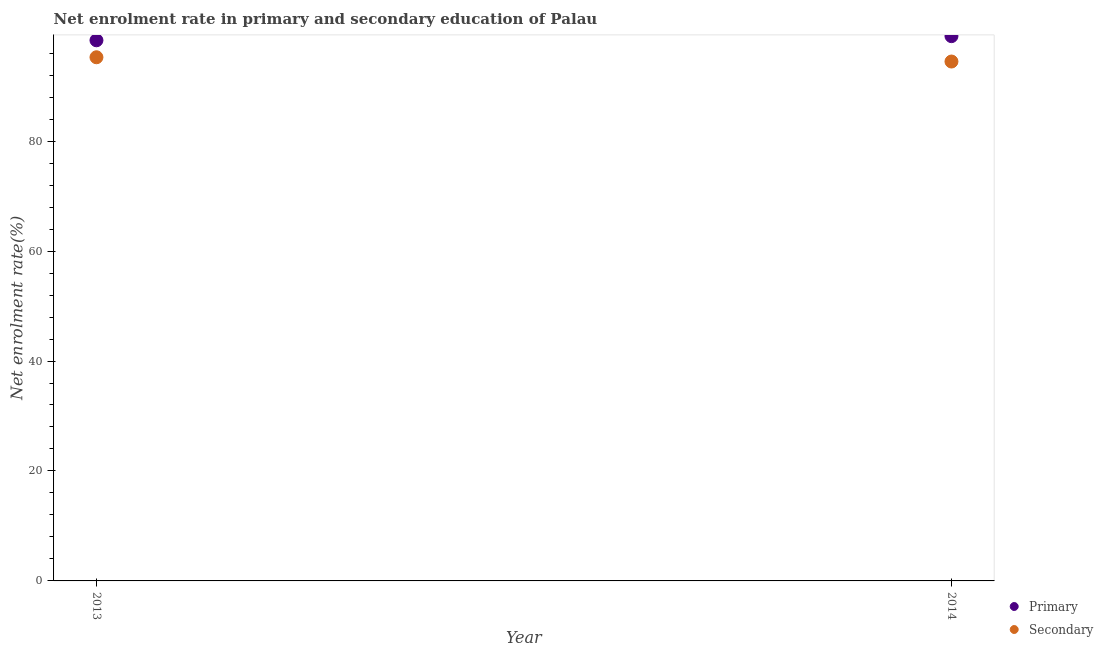What is the enrollment rate in secondary education in 2014?
Give a very brief answer. 94.48. Across all years, what is the maximum enrollment rate in secondary education?
Provide a succinct answer. 95.25. Across all years, what is the minimum enrollment rate in primary education?
Your response must be concise. 98.34. In which year was the enrollment rate in primary education minimum?
Make the answer very short. 2013. What is the total enrollment rate in primary education in the graph?
Your answer should be compact. 197.43. What is the difference between the enrollment rate in primary education in 2013 and that in 2014?
Offer a terse response. -0.75. What is the difference between the enrollment rate in primary education in 2014 and the enrollment rate in secondary education in 2013?
Provide a succinct answer. 3.84. What is the average enrollment rate in primary education per year?
Offer a very short reply. 98.72. In the year 2014, what is the difference between the enrollment rate in secondary education and enrollment rate in primary education?
Ensure brevity in your answer.  -4.62. What is the ratio of the enrollment rate in primary education in 2013 to that in 2014?
Ensure brevity in your answer.  0.99. Is the enrollment rate in primary education in 2013 less than that in 2014?
Keep it short and to the point. Yes. Does the enrollment rate in primary education monotonically increase over the years?
Provide a succinct answer. Yes. Is the enrollment rate in secondary education strictly greater than the enrollment rate in primary education over the years?
Make the answer very short. No. How many years are there in the graph?
Keep it short and to the point. 2. What is the difference between two consecutive major ticks on the Y-axis?
Your answer should be very brief. 20. Are the values on the major ticks of Y-axis written in scientific E-notation?
Make the answer very short. No. Does the graph contain grids?
Keep it short and to the point. No. Where does the legend appear in the graph?
Your answer should be compact. Bottom right. How are the legend labels stacked?
Your answer should be very brief. Vertical. What is the title of the graph?
Ensure brevity in your answer.  Net enrolment rate in primary and secondary education of Palau. What is the label or title of the X-axis?
Give a very brief answer. Year. What is the label or title of the Y-axis?
Ensure brevity in your answer.  Net enrolment rate(%). What is the Net enrolment rate(%) of Primary in 2013?
Make the answer very short. 98.34. What is the Net enrolment rate(%) of Secondary in 2013?
Give a very brief answer. 95.25. What is the Net enrolment rate(%) of Primary in 2014?
Offer a very short reply. 99.09. What is the Net enrolment rate(%) of Secondary in 2014?
Your response must be concise. 94.48. Across all years, what is the maximum Net enrolment rate(%) of Primary?
Keep it short and to the point. 99.09. Across all years, what is the maximum Net enrolment rate(%) of Secondary?
Your answer should be very brief. 95.25. Across all years, what is the minimum Net enrolment rate(%) in Primary?
Make the answer very short. 98.34. Across all years, what is the minimum Net enrolment rate(%) of Secondary?
Offer a terse response. 94.48. What is the total Net enrolment rate(%) of Primary in the graph?
Provide a succinct answer. 197.43. What is the total Net enrolment rate(%) of Secondary in the graph?
Give a very brief answer. 189.73. What is the difference between the Net enrolment rate(%) in Primary in 2013 and that in 2014?
Offer a terse response. -0.75. What is the difference between the Net enrolment rate(%) in Secondary in 2013 and that in 2014?
Provide a succinct answer. 0.78. What is the difference between the Net enrolment rate(%) in Primary in 2013 and the Net enrolment rate(%) in Secondary in 2014?
Provide a succinct answer. 3.86. What is the average Net enrolment rate(%) in Primary per year?
Ensure brevity in your answer.  98.72. What is the average Net enrolment rate(%) of Secondary per year?
Keep it short and to the point. 94.86. In the year 2013, what is the difference between the Net enrolment rate(%) in Primary and Net enrolment rate(%) in Secondary?
Provide a short and direct response. 3.09. In the year 2014, what is the difference between the Net enrolment rate(%) in Primary and Net enrolment rate(%) in Secondary?
Offer a terse response. 4.62. What is the ratio of the Net enrolment rate(%) in Primary in 2013 to that in 2014?
Your answer should be very brief. 0.99. What is the ratio of the Net enrolment rate(%) in Secondary in 2013 to that in 2014?
Keep it short and to the point. 1.01. What is the difference between the highest and the second highest Net enrolment rate(%) of Primary?
Make the answer very short. 0.75. What is the difference between the highest and the second highest Net enrolment rate(%) in Secondary?
Offer a terse response. 0.78. What is the difference between the highest and the lowest Net enrolment rate(%) in Primary?
Your answer should be very brief. 0.75. What is the difference between the highest and the lowest Net enrolment rate(%) of Secondary?
Provide a short and direct response. 0.78. 